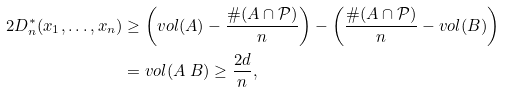Convert formula to latex. <formula><loc_0><loc_0><loc_500><loc_500>2 D _ { n } ^ { * } ( x _ { 1 } , \dots , x _ { n } ) & \geq \left ( v o l ( A ) - \frac { \# ( A \cap \mathcal { P } ) } { n } \right ) - \left ( \frac { \# ( A \cap \mathcal { P } ) } { n } - v o l ( B ) \right ) \\ & = v o l ( A \ B ) \geq \frac { 2 d } { n } ,</formula> 